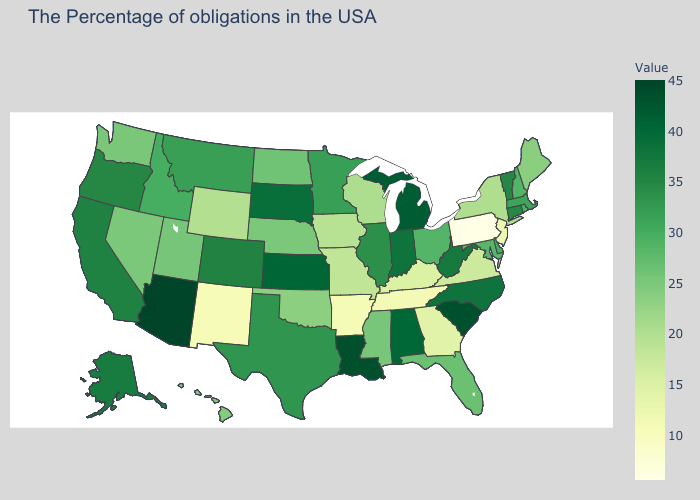Does the map have missing data?
Give a very brief answer. No. Does the map have missing data?
Keep it brief. No. Among the states that border North Dakota , which have the lowest value?
Write a very short answer. Minnesota. Among the states that border Georgia , does North Carolina have the highest value?
Answer briefly. No. Does Pennsylvania have the lowest value in the USA?
Concise answer only. Yes. Does Tennessee have the lowest value in the South?
Give a very brief answer. No. 